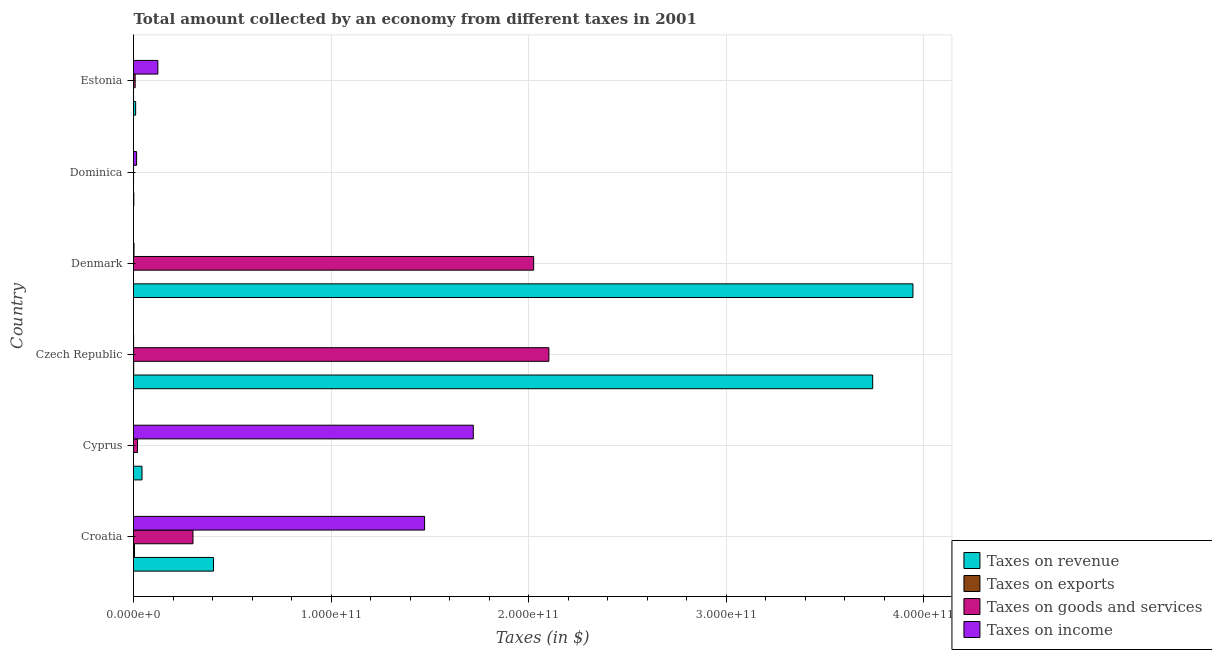How many different coloured bars are there?
Provide a short and direct response. 4. How many groups of bars are there?
Keep it short and to the point. 6. Are the number of bars per tick equal to the number of legend labels?
Your answer should be very brief. Yes. How many bars are there on the 5th tick from the bottom?
Make the answer very short. 4. What is the label of the 6th group of bars from the top?
Provide a short and direct response. Croatia. What is the amount collected as tax on exports in Croatia?
Your response must be concise. 4.93e+08. Across all countries, what is the maximum amount collected as tax on goods?
Your response must be concise. 2.10e+11. Across all countries, what is the minimum amount collected as tax on revenue?
Your response must be concise. 1.63e+08. In which country was the amount collected as tax on income maximum?
Offer a terse response. Cyprus. In which country was the amount collected as tax on goods minimum?
Provide a succinct answer. Dominica. What is the total amount collected as tax on exports in the graph?
Your answer should be very brief. 6.10e+08. What is the difference between the amount collected as tax on goods in Croatia and that in Cyprus?
Ensure brevity in your answer.  2.81e+1. What is the difference between the amount collected as tax on revenue in Croatia and the amount collected as tax on goods in Cyprus?
Offer a terse response. 3.85e+1. What is the average amount collected as tax on revenue per country?
Keep it short and to the point. 1.36e+11. What is the difference between the amount collected as tax on income and amount collected as tax on exports in Denmark?
Your response must be concise. 2.48e+08. What is the ratio of the amount collected as tax on income in Croatia to that in Dominica?
Provide a short and direct response. 93.61. Is the amount collected as tax on exports in Croatia less than that in Denmark?
Ensure brevity in your answer.  No. Is the difference between the amount collected as tax on goods in Cyprus and Estonia greater than the difference between the amount collected as tax on revenue in Cyprus and Estonia?
Provide a succinct answer. No. What is the difference between the highest and the second highest amount collected as tax on goods?
Make the answer very short. 7.71e+09. What is the difference between the highest and the lowest amount collected as tax on income?
Ensure brevity in your answer.  1.72e+11. What does the 1st bar from the top in Cyprus represents?
Make the answer very short. Taxes on income. What does the 1st bar from the bottom in Denmark represents?
Offer a terse response. Taxes on revenue. How many bars are there?
Make the answer very short. 24. What is the difference between two consecutive major ticks on the X-axis?
Offer a very short reply. 1.00e+11. Are the values on the major ticks of X-axis written in scientific E-notation?
Your answer should be compact. Yes. Does the graph contain grids?
Make the answer very short. Yes. What is the title of the graph?
Your response must be concise. Total amount collected by an economy from different taxes in 2001. Does "Quality of logistic services" appear as one of the legend labels in the graph?
Give a very brief answer. No. What is the label or title of the X-axis?
Offer a terse response. Taxes (in $). What is the Taxes (in $) in Taxes on revenue in Croatia?
Give a very brief answer. 4.05e+1. What is the Taxes (in $) in Taxes on exports in Croatia?
Make the answer very short. 4.93e+08. What is the Taxes (in $) of Taxes on goods and services in Croatia?
Keep it short and to the point. 3.01e+1. What is the Taxes (in $) of Taxes on income in Croatia?
Provide a short and direct response. 1.47e+11. What is the Taxes (in $) of Taxes on revenue in Cyprus?
Give a very brief answer. 4.30e+09. What is the Taxes (in $) of Taxes on goods and services in Cyprus?
Make the answer very short. 2.02e+09. What is the Taxes (in $) in Taxes on income in Cyprus?
Make the answer very short. 1.72e+11. What is the Taxes (in $) of Taxes on revenue in Czech Republic?
Offer a terse response. 3.74e+11. What is the Taxes (in $) of Taxes on exports in Czech Republic?
Provide a succinct answer. 9.83e+07. What is the Taxes (in $) in Taxes on goods and services in Czech Republic?
Make the answer very short. 2.10e+11. What is the Taxes (in $) of Taxes on income in Czech Republic?
Ensure brevity in your answer.  4.45e+07. What is the Taxes (in $) in Taxes on revenue in Denmark?
Give a very brief answer. 3.95e+11. What is the Taxes (in $) of Taxes on exports in Denmark?
Provide a succinct answer. 1.96e+06. What is the Taxes (in $) in Taxes on goods and services in Denmark?
Offer a very short reply. 2.03e+11. What is the Taxes (in $) of Taxes on income in Denmark?
Keep it short and to the point. 2.50e+08. What is the Taxes (in $) of Taxes on revenue in Dominica?
Ensure brevity in your answer.  1.63e+08. What is the Taxes (in $) of Taxes on exports in Dominica?
Give a very brief answer. 9.30e+06. What is the Taxes (in $) in Taxes on goods and services in Dominica?
Keep it short and to the point. 3.03e+07. What is the Taxes (in $) in Taxes on income in Dominica?
Your answer should be very brief. 1.57e+09. What is the Taxes (in $) of Taxes on revenue in Estonia?
Your answer should be very brief. 1.08e+09. What is the Taxes (in $) of Taxes on exports in Estonia?
Ensure brevity in your answer.  7.40e+06. What is the Taxes (in $) of Taxes on goods and services in Estonia?
Offer a very short reply. 8.27e+08. What is the Taxes (in $) in Taxes on income in Estonia?
Offer a terse response. 1.23e+1. Across all countries, what is the maximum Taxes (in $) of Taxes on revenue?
Make the answer very short. 3.95e+11. Across all countries, what is the maximum Taxes (in $) in Taxes on exports?
Give a very brief answer. 4.93e+08. Across all countries, what is the maximum Taxes (in $) of Taxes on goods and services?
Make the answer very short. 2.10e+11. Across all countries, what is the maximum Taxes (in $) of Taxes on income?
Your answer should be very brief. 1.72e+11. Across all countries, what is the minimum Taxes (in $) in Taxes on revenue?
Your answer should be compact. 1.63e+08. Across all countries, what is the minimum Taxes (in $) of Taxes on goods and services?
Provide a succinct answer. 3.03e+07. Across all countries, what is the minimum Taxes (in $) of Taxes on income?
Keep it short and to the point. 4.45e+07. What is the total Taxes (in $) in Taxes on revenue in the graph?
Offer a terse response. 8.15e+11. What is the total Taxes (in $) of Taxes on exports in the graph?
Ensure brevity in your answer.  6.10e+08. What is the total Taxes (in $) in Taxes on goods and services in the graph?
Make the answer very short. 4.46e+11. What is the total Taxes (in $) of Taxes on income in the graph?
Make the answer very short. 3.34e+11. What is the difference between the Taxes (in $) in Taxes on revenue in Croatia and that in Cyprus?
Keep it short and to the point. 3.62e+1. What is the difference between the Taxes (in $) in Taxes on exports in Croatia and that in Cyprus?
Make the answer very short. 4.93e+08. What is the difference between the Taxes (in $) of Taxes on goods and services in Croatia and that in Cyprus?
Provide a short and direct response. 2.81e+1. What is the difference between the Taxes (in $) in Taxes on income in Croatia and that in Cyprus?
Your response must be concise. -2.47e+1. What is the difference between the Taxes (in $) in Taxes on revenue in Croatia and that in Czech Republic?
Provide a succinct answer. -3.34e+11. What is the difference between the Taxes (in $) of Taxes on exports in Croatia and that in Czech Republic?
Ensure brevity in your answer.  3.95e+08. What is the difference between the Taxes (in $) of Taxes on goods and services in Croatia and that in Czech Republic?
Keep it short and to the point. -1.80e+11. What is the difference between the Taxes (in $) of Taxes on income in Croatia and that in Czech Republic?
Offer a very short reply. 1.47e+11. What is the difference between the Taxes (in $) in Taxes on revenue in Croatia and that in Denmark?
Your answer should be very brief. -3.54e+11. What is the difference between the Taxes (in $) of Taxes on exports in Croatia and that in Denmark?
Your answer should be very brief. 4.91e+08. What is the difference between the Taxes (in $) in Taxes on goods and services in Croatia and that in Denmark?
Your answer should be compact. -1.73e+11. What is the difference between the Taxes (in $) of Taxes on income in Croatia and that in Denmark?
Ensure brevity in your answer.  1.47e+11. What is the difference between the Taxes (in $) of Taxes on revenue in Croatia and that in Dominica?
Keep it short and to the point. 4.03e+1. What is the difference between the Taxes (in $) in Taxes on exports in Croatia and that in Dominica?
Ensure brevity in your answer.  4.84e+08. What is the difference between the Taxes (in $) of Taxes on goods and services in Croatia and that in Dominica?
Your response must be concise. 3.01e+1. What is the difference between the Taxes (in $) of Taxes on income in Croatia and that in Dominica?
Make the answer very short. 1.46e+11. What is the difference between the Taxes (in $) in Taxes on revenue in Croatia and that in Estonia?
Provide a short and direct response. 3.94e+1. What is the difference between the Taxes (in $) in Taxes on exports in Croatia and that in Estonia?
Your response must be concise. 4.86e+08. What is the difference between the Taxes (in $) of Taxes on goods and services in Croatia and that in Estonia?
Your answer should be compact. 2.93e+1. What is the difference between the Taxes (in $) in Taxes on income in Croatia and that in Estonia?
Make the answer very short. 1.35e+11. What is the difference between the Taxes (in $) in Taxes on revenue in Cyprus and that in Czech Republic?
Provide a short and direct response. -3.70e+11. What is the difference between the Taxes (in $) of Taxes on exports in Cyprus and that in Czech Republic?
Provide a succinct answer. -9.83e+07. What is the difference between the Taxes (in $) in Taxes on goods and services in Cyprus and that in Czech Republic?
Ensure brevity in your answer.  -2.08e+11. What is the difference between the Taxes (in $) in Taxes on income in Cyprus and that in Czech Republic?
Offer a very short reply. 1.72e+11. What is the difference between the Taxes (in $) in Taxes on revenue in Cyprus and that in Denmark?
Make the answer very short. -3.90e+11. What is the difference between the Taxes (in $) of Taxes on exports in Cyprus and that in Denmark?
Make the answer very short. -1.92e+06. What is the difference between the Taxes (in $) of Taxes on goods and services in Cyprus and that in Denmark?
Your answer should be very brief. -2.01e+11. What is the difference between the Taxes (in $) of Taxes on income in Cyprus and that in Denmark?
Provide a succinct answer. 1.72e+11. What is the difference between the Taxes (in $) of Taxes on revenue in Cyprus and that in Dominica?
Your answer should be very brief. 4.14e+09. What is the difference between the Taxes (in $) in Taxes on exports in Cyprus and that in Dominica?
Keep it short and to the point. -9.26e+06. What is the difference between the Taxes (in $) in Taxes on goods and services in Cyprus and that in Dominica?
Provide a short and direct response. 1.99e+09. What is the difference between the Taxes (in $) of Taxes on income in Cyprus and that in Dominica?
Provide a short and direct response. 1.70e+11. What is the difference between the Taxes (in $) of Taxes on revenue in Cyprus and that in Estonia?
Provide a succinct answer. 3.22e+09. What is the difference between the Taxes (in $) of Taxes on exports in Cyprus and that in Estonia?
Your answer should be compact. -7.36e+06. What is the difference between the Taxes (in $) of Taxes on goods and services in Cyprus and that in Estonia?
Your response must be concise. 1.20e+09. What is the difference between the Taxes (in $) of Taxes on income in Cyprus and that in Estonia?
Offer a very short reply. 1.60e+11. What is the difference between the Taxes (in $) of Taxes on revenue in Czech Republic and that in Denmark?
Offer a terse response. -2.04e+1. What is the difference between the Taxes (in $) of Taxes on exports in Czech Republic and that in Denmark?
Give a very brief answer. 9.64e+07. What is the difference between the Taxes (in $) in Taxes on goods and services in Czech Republic and that in Denmark?
Your answer should be very brief. 7.71e+09. What is the difference between the Taxes (in $) of Taxes on income in Czech Republic and that in Denmark?
Provide a short and direct response. -2.05e+08. What is the difference between the Taxes (in $) of Taxes on revenue in Czech Republic and that in Dominica?
Your response must be concise. 3.74e+11. What is the difference between the Taxes (in $) in Taxes on exports in Czech Republic and that in Dominica?
Your answer should be compact. 8.90e+07. What is the difference between the Taxes (in $) of Taxes on goods and services in Czech Republic and that in Dominica?
Keep it short and to the point. 2.10e+11. What is the difference between the Taxes (in $) of Taxes on income in Czech Republic and that in Dominica?
Provide a short and direct response. -1.53e+09. What is the difference between the Taxes (in $) of Taxes on revenue in Czech Republic and that in Estonia?
Your response must be concise. 3.73e+11. What is the difference between the Taxes (in $) in Taxes on exports in Czech Republic and that in Estonia?
Offer a terse response. 9.09e+07. What is the difference between the Taxes (in $) in Taxes on goods and services in Czech Republic and that in Estonia?
Provide a short and direct response. 2.09e+11. What is the difference between the Taxes (in $) of Taxes on income in Czech Republic and that in Estonia?
Give a very brief answer. -1.23e+1. What is the difference between the Taxes (in $) of Taxes on revenue in Denmark and that in Dominica?
Make the answer very short. 3.95e+11. What is the difference between the Taxes (in $) in Taxes on exports in Denmark and that in Dominica?
Your answer should be compact. -7.34e+06. What is the difference between the Taxes (in $) of Taxes on goods and services in Denmark and that in Dominica?
Offer a very short reply. 2.03e+11. What is the difference between the Taxes (in $) of Taxes on income in Denmark and that in Dominica?
Offer a terse response. -1.32e+09. What is the difference between the Taxes (in $) of Taxes on revenue in Denmark and that in Estonia?
Offer a terse response. 3.94e+11. What is the difference between the Taxes (in $) in Taxes on exports in Denmark and that in Estonia?
Give a very brief answer. -5.44e+06. What is the difference between the Taxes (in $) of Taxes on goods and services in Denmark and that in Estonia?
Offer a terse response. 2.02e+11. What is the difference between the Taxes (in $) of Taxes on income in Denmark and that in Estonia?
Provide a short and direct response. -1.21e+1. What is the difference between the Taxes (in $) in Taxes on revenue in Dominica and that in Estonia?
Make the answer very short. -9.16e+08. What is the difference between the Taxes (in $) of Taxes on exports in Dominica and that in Estonia?
Keep it short and to the point. 1.90e+06. What is the difference between the Taxes (in $) in Taxes on goods and services in Dominica and that in Estonia?
Ensure brevity in your answer.  -7.97e+08. What is the difference between the Taxes (in $) of Taxes on income in Dominica and that in Estonia?
Ensure brevity in your answer.  -1.08e+1. What is the difference between the Taxes (in $) of Taxes on revenue in Croatia and the Taxes (in $) of Taxes on exports in Cyprus?
Offer a terse response. 4.05e+1. What is the difference between the Taxes (in $) in Taxes on revenue in Croatia and the Taxes (in $) in Taxes on goods and services in Cyprus?
Your response must be concise. 3.85e+1. What is the difference between the Taxes (in $) in Taxes on revenue in Croatia and the Taxes (in $) in Taxes on income in Cyprus?
Your answer should be very brief. -1.32e+11. What is the difference between the Taxes (in $) of Taxes on exports in Croatia and the Taxes (in $) of Taxes on goods and services in Cyprus?
Your answer should be compact. -1.53e+09. What is the difference between the Taxes (in $) of Taxes on exports in Croatia and the Taxes (in $) of Taxes on income in Cyprus?
Give a very brief answer. -1.72e+11. What is the difference between the Taxes (in $) in Taxes on goods and services in Croatia and the Taxes (in $) in Taxes on income in Cyprus?
Your response must be concise. -1.42e+11. What is the difference between the Taxes (in $) in Taxes on revenue in Croatia and the Taxes (in $) in Taxes on exports in Czech Republic?
Your answer should be very brief. 4.04e+1. What is the difference between the Taxes (in $) of Taxes on revenue in Croatia and the Taxes (in $) of Taxes on goods and services in Czech Republic?
Make the answer very short. -1.70e+11. What is the difference between the Taxes (in $) in Taxes on revenue in Croatia and the Taxes (in $) in Taxes on income in Czech Republic?
Your response must be concise. 4.04e+1. What is the difference between the Taxes (in $) of Taxes on exports in Croatia and the Taxes (in $) of Taxes on goods and services in Czech Republic?
Make the answer very short. -2.10e+11. What is the difference between the Taxes (in $) in Taxes on exports in Croatia and the Taxes (in $) in Taxes on income in Czech Republic?
Your answer should be compact. 4.48e+08. What is the difference between the Taxes (in $) of Taxes on goods and services in Croatia and the Taxes (in $) of Taxes on income in Czech Republic?
Your answer should be compact. 3.01e+1. What is the difference between the Taxes (in $) of Taxes on revenue in Croatia and the Taxes (in $) of Taxes on exports in Denmark?
Provide a short and direct response. 4.05e+1. What is the difference between the Taxes (in $) of Taxes on revenue in Croatia and the Taxes (in $) of Taxes on goods and services in Denmark?
Provide a short and direct response. -1.62e+11. What is the difference between the Taxes (in $) of Taxes on revenue in Croatia and the Taxes (in $) of Taxes on income in Denmark?
Offer a very short reply. 4.02e+1. What is the difference between the Taxes (in $) in Taxes on exports in Croatia and the Taxes (in $) in Taxes on goods and services in Denmark?
Ensure brevity in your answer.  -2.02e+11. What is the difference between the Taxes (in $) of Taxes on exports in Croatia and the Taxes (in $) of Taxes on income in Denmark?
Ensure brevity in your answer.  2.43e+08. What is the difference between the Taxes (in $) in Taxes on goods and services in Croatia and the Taxes (in $) in Taxes on income in Denmark?
Offer a terse response. 2.99e+1. What is the difference between the Taxes (in $) in Taxes on revenue in Croatia and the Taxes (in $) in Taxes on exports in Dominica?
Provide a short and direct response. 4.05e+1. What is the difference between the Taxes (in $) in Taxes on revenue in Croatia and the Taxes (in $) in Taxes on goods and services in Dominica?
Keep it short and to the point. 4.05e+1. What is the difference between the Taxes (in $) of Taxes on revenue in Croatia and the Taxes (in $) of Taxes on income in Dominica?
Provide a succinct answer. 3.89e+1. What is the difference between the Taxes (in $) of Taxes on exports in Croatia and the Taxes (in $) of Taxes on goods and services in Dominica?
Ensure brevity in your answer.  4.63e+08. What is the difference between the Taxes (in $) of Taxes on exports in Croatia and the Taxes (in $) of Taxes on income in Dominica?
Ensure brevity in your answer.  -1.08e+09. What is the difference between the Taxes (in $) in Taxes on goods and services in Croatia and the Taxes (in $) in Taxes on income in Dominica?
Offer a terse response. 2.85e+1. What is the difference between the Taxes (in $) in Taxes on revenue in Croatia and the Taxes (in $) in Taxes on exports in Estonia?
Offer a terse response. 4.05e+1. What is the difference between the Taxes (in $) in Taxes on revenue in Croatia and the Taxes (in $) in Taxes on goods and services in Estonia?
Provide a short and direct response. 3.97e+1. What is the difference between the Taxes (in $) in Taxes on revenue in Croatia and the Taxes (in $) in Taxes on income in Estonia?
Make the answer very short. 2.81e+1. What is the difference between the Taxes (in $) in Taxes on exports in Croatia and the Taxes (in $) in Taxes on goods and services in Estonia?
Provide a short and direct response. -3.34e+08. What is the difference between the Taxes (in $) in Taxes on exports in Croatia and the Taxes (in $) in Taxes on income in Estonia?
Offer a very short reply. -1.18e+1. What is the difference between the Taxes (in $) of Taxes on goods and services in Croatia and the Taxes (in $) of Taxes on income in Estonia?
Make the answer very short. 1.78e+1. What is the difference between the Taxes (in $) of Taxes on revenue in Cyprus and the Taxes (in $) of Taxes on exports in Czech Republic?
Offer a very short reply. 4.20e+09. What is the difference between the Taxes (in $) in Taxes on revenue in Cyprus and the Taxes (in $) in Taxes on goods and services in Czech Republic?
Ensure brevity in your answer.  -2.06e+11. What is the difference between the Taxes (in $) in Taxes on revenue in Cyprus and the Taxes (in $) in Taxes on income in Czech Republic?
Offer a terse response. 4.26e+09. What is the difference between the Taxes (in $) of Taxes on exports in Cyprus and the Taxes (in $) of Taxes on goods and services in Czech Republic?
Provide a short and direct response. -2.10e+11. What is the difference between the Taxes (in $) of Taxes on exports in Cyprus and the Taxes (in $) of Taxes on income in Czech Republic?
Ensure brevity in your answer.  -4.45e+07. What is the difference between the Taxes (in $) in Taxes on goods and services in Cyprus and the Taxes (in $) in Taxes on income in Czech Republic?
Provide a succinct answer. 1.98e+09. What is the difference between the Taxes (in $) in Taxes on revenue in Cyprus and the Taxes (in $) in Taxes on exports in Denmark?
Give a very brief answer. 4.30e+09. What is the difference between the Taxes (in $) of Taxes on revenue in Cyprus and the Taxes (in $) of Taxes on goods and services in Denmark?
Your answer should be compact. -1.98e+11. What is the difference between the Taxes (in $) of Taxes on revenue in Cyprus and the Taxes (in $) of Taxes on income in Denmark?
Give a very brief answer. 4.05e+09. What is the difference between the Taxes (in $) of Taxes on exports in Cyprus and the Taxes (in $) of Taxes on goods and services in Denmark?
Offer a terse response. -2.03e+11. What is the difference between the Taxes (in $) of Taxes on exports in Cyprus and the Taxes (in $) of Taxes on income in Denmark?
Offer a terse response. -2.50e+08. What is the difference between the Taxes (in $) of Taxes on goods and services in Cyprus and the Taxes (in $) of Taxes on income in Denmark?
Keep it short and to the point. 1.77e+09. What is the difference between the Taxes (in $) in Taxes on revenue in Cyprus and the Taxes (in $) in Taxes on exports in Dominica?
Your answer should be compact. 4.29e+09. What is the difference between the Taxes (in $) of Taxes on revenue in Cyprus and the Taxes (in $) of Taxes on goods and services in Dominica?
Your answer should be very brief. 4.27e+09. What is the difference between the Taxes (in $) in Taxes on revenue in Cyprus and the Taxes (in $) in Taxes on income in Dominica?
Make the answer very short. 2.73e+09. What is the difference between the Taxes (in $) in Taxes on exports in Cyprus and the Taxes (in $) in Taxes on goods and services in Dominica?
Your response must be concise. -3.03e+07. What is the difference between the Taxes (in $) in Taxes on exports in Cyprus and the Taxes (in $) in Taxes on income in Dominica?
Provide a succinct answer. -1.57e+09. What is the difference between the Taxes (in $) of Taxes on goods and services in Cyprus and the Taxes (in $) of Taxes on income in Dominica?
Your answer should be compact. 4.49e+08. What is the difference between the Taxes (in $) in Taxes on revenue in Cyprus and the Taxes (in $) in Taxes on exports in Estonia?
Your response must be concise. 4.29e+09. What is the difference between the Taxes (in $) in Taxes on revenue in Cyprus and the Taxes (in $) in Taxes on goods and services in Estonia?
Your answer should be very brief. 3.47e+09. What is the difference between the Taxes (in $) in Taxes on revenue in Cyprus and the Taxes (in $) in Taxes on income in Estonia?
Provide a short and direct response. -8.04e+09. What is the difference between the Taxes (in $) of Taxes on exports in Cyprus and the Taxes (in $) of Taxes on goods and services in Estonia?
Offer a very short reply. -8.27e+08. What is the difference between the Taxes (in $) in Taxes on exports in Cyprus and the Taxes (in $) in Taxes on income in Estonia?
Give a very brief answer. -1.23e+1. What is the difference between the Taxes (in $) in Taxes on goods and services in Cyprus and the Taxes (in $) in Taxes on income in Estonia?
Your answer should be compact. -1.03e+1. What is the difference between the Taxes (in $) in Taxes on revenue in Czech Republic and the Taxes (in $) in Taxes on exports in Denmark?
Give a very brief answer. 3.74e+11. What is the difference between the Taxes (in $) in Taxes on revenue in Czech Republic and the Taxes (in $) in Taxes on goods and services in Denmark?
Provide a short and direct response. 1.72e+11. What is the difference between the Taxes (in $) of Taxes on revenue in Czech Republic and the Taxes (in $) of Taxes on income in Denmark?
Your answer should be compact. 3.74e+11. What is the difference between the Taxes (in $) in Taxes on exports in Czech Republic and the Taxes (in $) in Taxes on goods and services in Denmark?
Offer a very short reply. -2.03e+11. What is the difference between the Taxes (in $) in Taxes on exports in Czech Republic and the Taxes (in $) in Taxes on income in Denmark?
Give a very brief answer. -1.51e+08. What is the difference between the Taxes (in $) of Taxes on goods and services in Czech Republic and the Taxes (in $) of Taxes on income in Denmark?
Provide a succinct answer. 2.10e+11. What is the difference between the Taxes (in $) of Taxes on revenue in Czech Republic and the Taxes (in $) of Taxes on exports in Dominica?
Ensure brevity in your answer.  3.74e+11. What is the difference between the Taxes (in $) of Taxes on revenue in Czech Republic and the Taxes (in $) of Taxes on goods and services in Dominica?
Provide a short and direct response. 3.74e+11. What is the difference between the Taxes (in $) of Taxes on revenue in Czech Republic and the Taxes (in $) of Taxes on income in Dominica?
Your response must be concise. 3.73e+11. What is the difference between the Taxes (in $) of Taxes on exports in Czech Republic and the Taxes (in $) of Taxes on goods and services in Dominica?
Keep it short and to the point. 6.80e+07. What is the difference between the Taxes (in $) in Taxes on exports in Czech Republic and the Taxes (in $) in Taxes on income in Dominica?
Your response must be concise. -1.48e+09. What is the difference between the Taxes (in $) of Taxes on goods and services in Czech Republic and the Taxes (in $) of Taxes on income in Dominica?
Provide a succinct answer. 2.09e+11. What is the difference between the Taxes (in $) of Taxes on revenue in Czech Republic and the Taxes (in $) of Taxes on exports in Estonia?
Make the answer very short. 3.74e+11. What is the difference between the Taxes (in $) in Taxes on revenue in Czech Republic and the Taxes (in $) in Taxes on goods and services in Estonia?
Make the answer very short. 3.73e+11. What is the difference between the Taxes (in $) of Taxes on revenue in Czech Republic and the Taxes (in $) of Taxes on income in Estonia?
Ensure brevity in your answer.  3.62e+11. What is the difference between the Taxes (in $) in Taxes on exports in Czech Republic and the Taxes (in $) in Taxes on goods and services in Estonia?
Your answer should be very brief. -7.29e+08. What is the difference between the Taxes (in $) in Taxes on exports in Czech Republic and the Taxes (in $) in Taxes on income in Estonia?
Your answer should be very brief. -1.22e+1. What is the difference between the Taxes (in $) of Taxes on goods and services in Czech Republic and the Taxes (in $) of Taxes on income in Estonia?
Offer a terse response. 1.98e+11. What is the difference between the Taxes (in $) in Taxes on revenue in Denmark and the Taxes (in $) in Taxes on exports in Dominica?
Your answer should be compact. 3.95e+11. What is the difference between the Taxes (in $) in Taxes on revenue in Denmark and the Taxes (in $) in Taxes on goods and services in Dominica?
Give a very brief answer. 3.95e+11. What is the difference between the Taxes (in $) in Taxes on revenue in Denmark and the Taxes (in $) in Taxes on income in Dominica?
Keep it short and to the point. 3.93e+11. What is the difference between the Taxes (in $) of Taxes on exports in Denmark and the Taxes (in $) of Taxes on goods and services in Dominica?
Offer a very short reply. -2.83e+07. What is the difference between the Taxes (in $) in Taxes on exports in Denmark and the Taxes (in $) in Taxes on income in Dominica?
Your response must be concise. -1.57e+09. What is the difference between the Taxes (in $) in Taxes on goods and services in Denmark and the Taxes (in $) in Taxes on income in Dominica?
Your answer should be compact. 2.01e+11. What is the difference between the Taxes (in $) of Taxes on revenue in Denmark and the Taxes (in $) of Taxes on exports in Estonia?
Offer a terse response. 3.95e+11. What is the difference between the Taxes (in $) of Taxes on revenue in Denmark and the Taxes (in $) of Taxes on goods and services in Estonia?
Provide a short and direct response. 3.94e+11. What is the difference between the Taxes (in $) in Taxes on revenue in Denmark and the Taxes (in $) in Taxes on income in Estonia?
Your answer should be compact. 3.82e+11. What is the difference between the Taxes (in $) in Taxes on exports in Denmark and the Taxes (in $) in Taxes on goods and services in Estonia?
Give a very brief answer. -8.25e+08. What is the difference between the Taxes (in $) in Taxes on exports in Denmark and the Taxes (in $) in Taxes on income in Estonia?
Your response must be concise. -1.23e+1. What is the difference between the Taxes (in $) of Taxes on goods and services in Denmark and the Taxes (in $) of Taxes on income in Estonia?
Your answer should be compact. 1.90e+11. What is the difference between the Taxes (in $) of Taxes on revenue in Dominica and the Taxes (in $) of Taxes on exports in Estonia?
Make the answer very short. 1.56e+08. What is the difference between the Taxes (in $) in Taxes on revenue in Dominica and the Taxes (in $) in Taxes on goods and services in Estonia?
Your answer should be very brief. -6.64e+08. What is the difference between the Taxes (in $) of Taxes on revenue in Dominica and the Taxes (in $) of Taxes on income in Estonia?
Give a very brief answer. -1.22e+1. What is the difference between the Taxes (in $) of Taxes on exports in Dominica and the Taxes (in $) of Taxes on goods and services in Estonia?
Ensure brevity in your answer.  -8.18e+08. What is the difference between the Taxes (in $) of Taxes on exports in Dominica and the Taxes (in $) of Taxes on income in Estonia?
Ensure brevity in your answer.  -1.23e+1. What is the difference between the Taxes (in $) in Taxes on goods and services in Dominica and the Taxes (in $) in Taxes on income in Estonia?
Offer a very short reply. -1.23e+1. What is the average Taxes (in $) in Taxes on revenue per country?
Provide a short and direct response. 1.36e+11. What is the average Taxes (in $) in Taxes on exports per country?
Provide a succinct answer. 1.02e+08. What is the average Taxes (in $) of Taxes on goods and services per country?
Offer a terse response. 7.43e+1. What is the average Taxes (in $) of Taxes on income per country?
Keep it short and to the point. 5.56e+1. What is the difference between the Taxes (in $) of Taxes on revenue and Taxes (in $) of Taxes on exports in Croatia?
Ensure brevity in your answer.  4.00e+1. What is the difference between the Taxes (in $) of Taxes on revenue and Taxes (in $) of Taxes on goods and services in Croatia?
Offer a terse response. 1.04e+1. What is the difference between the Taxes (in $) in Taxes on revenue and Taxes (in $) in Taxes on income in Croatia?
Offer a very short reply. -1.07e+11. What is the difference between the Taxes (in $) of Taxes on exports and Taxes (in $) of Taxes on goods and services in Croatia?
Your response must be concise. -2.96e+1. What is the difference between the Taxes (in $) of Taxes on exports and Taxes (in $) of Taxes on income in Croatia?
Ensure brevity in your answer.  -1.47e+11. What is the difference between the Taxes (in $) of Taxes on goods and services and Taxes (in $) of Taxes on income in Croatia?
Offer a terse response. -1.17e+11. What is the difference between the Taxes (in $) of Taxes on revenue and Taxes (in $) of Taxes on exports in Cyprus?
Offer a very short reply. 4.30e+09. What is the difference between the Taxes (in $) in Taxes on revenue and Taxes (in $) in Taxes on goods and services in Cyprus?
Provide a short and direct response. 2.28e+09. What is the difference between the Taxes (in $) in Taxes on revenue and Taxes (in $) in Taxes on income in Cyprus?
Make the answer very short. -1.68e+11. What is the difference between the Taxes (in $) in Taxes on exports and Taxes (in $) in Taxes on goods and services in Cyprus?
Make the answer very short. -2.02e+09. What is the difference between the Taxes (in $) of Taxes on exports and Taxes (in $) of Taxes on income in Cyprus?
Offer a terse response. -1.72e+11. What is the difference between the Taxes (in $) in Taxes on goods and services and Taxes (in $) in Taxes on income in Cyprus?
Offer a very short reply. -1.70e+11. What is the difference between the Taxes (in $) of Taxes on revenue and Taxes (in $) of Taxes on exports in Czech Republic?
Ensure brevity in your answer.  3.74e+11. What is the difference between the Taxes (in $) in Taxes on revenue and Taxes (in $) in Taxes on goods and services in Czech Republic?
Your answer should be compact. 1.64e+11. What is the difference between the Taxes (in $) in Taxes on revenue and Taxes (in $) in Taxes on income in Czech Republic?
Ensure brevity in your answer.  3.74e+11. What is the difference between the Taxes (in $) of Taxes on exports and Taxes (in $) of Taxes on goods and services in Czech Republic?
Keep it short and to the point. -2.10e+11. What is the difference between the Taxes (in $) of Taxes on exports and Taxes (in $) of Taxes on income in Czech Republic?
Offer a very short reply. 5.38e+07. What is the difference between the Taxes (in $) of Taxes on goods and services and Taxes (in $) of Taxes on income in Czech Republic?
Give a very brief answer. 2.10e+11. What is the difference between the Taxes (in $) of Taxes on revenue and Taxes (in $) of Taxes on exports in Denmark?
Provide a short and direct response. 3.95e+11. What is the difference between the Taxes (in $) of Taxes on revenue and Taxes (in $) of Taxes on goods and services in Denmark?
Provide a short and direct response. 1.92e+11. What is the difference between the Taxes (in $) in Taxes on revenue and Taxes (in $) in Taxes on income in Denmark?
Make the answer very short. 3.94e+11. What is the difference between the Taxes (in $) in Taxes on exports and Taxes (in $) in Taxes on goods and services in Denmark?
Offer a very short reply. -2.03e+11. What is the difference between the Taxes (in $) in Taxes on exports and Taxes (in $) in Taxes on income in Denmark?
Your answer should be very brief. -2.48e+08. What is the difference between the Taxes (in $) of Taxes on goods and services and Taxes (in $) of Taxes on income in Denmark?
Offer a very short reply. 2.02e+11. What is the difference between the Taxes (in $) in Taxes on revenue and Taxes (in $) in Taxes on exports in Dominica?
Your answer should be compact. 1.54e+08. What is the difference between the Taxes (in $) in Taxes on revenue and Taxes (in $) in Taxes on goods and services in Dominica?
Offer a terse response. 1.33e+08. What is the difference between the Taxes (in $) in Taxes on revenue and Taxes (in $) in Taxes on income in Dominica?
Your answer should be very brief. -1.41e+09. What is the difference between the Taxes (in $) of Taxes on exports and Taxes (in $) of Taxes on goods and services in Dominica?
Offer a very short reply. -2.10e+07. What is the difference between the Taxes (in $) of Taxes on exports and Taxes (in $) of Taxes on income in Dominica?
Provide a succinct answer. -1.57e+09. What is the difference between the Taxes (in $) of Taxes on goods and services and Taxes (in $) of Taxes on income in Dominica?
Provide a short and direct response. -1.54e+09. What is the difference between the Taxes (in $) of Taxes on revenue and Taxes (in $) of Taxes on exports in Estonia?
Make the answer very short. 1.07e+09. What is the difference between the Taxes (in $) in Taxes on revenue and Taxes (in $) in Taxes on goods and services in Estonia?
Ensure brevity in your answer.  2.52e+08. What is the difference between the Taxes (in $) of Taxes on revenue and Taxes (in $) of Taxes on income in Estonia?
Your answer should be very brief. -1.13e+1. What is the difference between the Taxes (in $) of Taxes on exports and Taxes (in $) of Taxes on goods and services in Estonia?
Your answer should be compact. -8.20e+08. What is the difference between the Taxes (in $) of Taxes on exports and Taxes (in $) of Taxes on income in Estonia?
Ensure brevity in your answer.  -1.23e+1. What is the difference between the Taxes (in $) of Taxes on goods and services and Taxes (in $) of Taxes on income in Estonia?
Offer a very short reply. -1.15e+1. What is the ratio of the Taxes (in $) in Taxes on revenue in Croatia to that in Cyprus?
Your answer should be very brief. 9.42. What is the ratio of the Taxes (in $) of Taxes on exports in Croatia to that in Cyprus?
Make the answer very short. 1.23e+04. What is the ratio of the Taxes (in $) of Taxes on goods and services in Croatia to that in Cyprus?
Make the answer very short. 14.88. What is the ratio of the Taxes (in $) of Taxes on income in Croatia to that in Cyprus?
Provide a succinct answer. 0.86. What is the ratio of the Taxes (in $) in Taxes on revenue in Croatia to that in Czech Republic?
Ensure brevity in your answer.  0.11. What is the ratio of the Taxes (in $) in Taxes on exports in Croatia to that in Czech Republic?
Provide a succinct answer. 5.01. What is the ratio of the Taxes (in $) of Taxes on goods and services in Croatia to that in Czech Republic?
Provide a succinct answer. 0.14. What is the ratio of the Taxes (in $) in Taxes on income in Croatia to that in Czech Republic?
Give a very brief answer. 3312.09. What is the ratio of the Taxes (in $) in Taxes on revenue in Croatia to that in Denmark?
Provide a short and direct response. 0.1. What is the ratio of the Taxes (in $) of Taxes on exports in Croatia to that in Denmark?
Your response must be concise. 251.71. What is the ratio of the Taxes (in $) of Taxes on goods and services in Croatia to that in Denmark?
Provide a succinct answer. 0.15. What is the ratio of the Taxes (in $) in Taxes on income in Croatia to that in Denmark?
Provide a succinct answer. 590.52. What is the ratio of the Taxes (in $) of Taxes on revenue in Croatia to that in Dominica?
Provide a succinct answer. 248.57. What is the ratio of the Taxes (in $) in Taxes on exports in Croatia to that in Dominica?
Give a very brief answer. 53.01. What is the ratio of the Taxes (in $) of Taxes on goods and services in Croatia to that in Dominica?
Offer a very short reply. 993.6. What is the ratio of the Taxes (in $) in Taxes on income in Croatia to that in Dominica?
Provide a short and direct response. 93.62. What is the ratio of the Taxes (in $) of Taxes on revenue in Croatia to that in Estonia?
Offer a very short reply. 37.51. What is the ratio of the Taxes (in $) in Taxes on exports in Croatia to that in Estonia?
Your answer should be very brief. 66.62. What is the ratio of the Taxes (in $) in Taxes on goods and services in Croatia to that in Estonia?
Make the answer very short. 36.39. What is the ratio of the Taxes (in $) of Taxes on income in Croatia to that in Estonia?
Keep it short and to the point. 11.94. What is the ratio of the Taxes (in $) of Taxes on revenue in Cyprus to that in Czech Republic?
Your answer should be very brief. 0.01. What is the ratio of the Taxes (in $) in Taxes on exports in Cyprus to that in Czech Republic?
Offer a terse response. 0. What is the ratio of the Taxes (in $) of Taxes on goods and services in Cyprus to that in Czech Republic?
Your answer should be very brief. 0.01. What is the ratio of the Taxes (in $) in Taxes on income in Cyprus to that in Czech Republic?
Offer a very short reply. 3866.47. What is the ratio of the Taxes (in $) of Taxes on revenue in Cyprus to that in Denmark?
Ensure brevity in your answer.  0.01. What is the ratio of the Taxes (in $) of Taxes on exports in Cyprus to that in Denmark?
Your response must be concise. 0.02. What is the ratio of the Taxes (in $) of Taxes on income in Cyprus to that in Denmark?
Offer a terse response. 689.36. What is the ratio of the Taxes (in $) in Taxes on revenue in Cyprus to that in Dominica?
Give a very brief answer. 26.4. What is the ratio of the Taxes (in $) in Taxes on exports in Cyprus to that in Dominica?
Ensure brevity in your answer.  0. What is the ratio of the Taxes (in $) in Taxes on goods and services in Cyprus to that in Dominica?
Provide a succinct answer. 66.77. What is the ratio of the Taxes (in $) in Taxes on income in Cyprus to that in Dominica?
Offer a very short reply. 109.28. What is the ratio of the Taxes (in $) in Taxes on revenue in Cyprus to that in Estonia?
Give a very brief answer. 3.98. What is the ratio of the Taxes (in $) in Taxes on exports in Cyprus to that in Estonia?
Your answer should be compact. 0.01. What is the ratio of the Taxes (in $) in Taxes on goods and services in Cyprus to that in Estonia?
Provide a short and direct response. 2.45. What is the ratio of the Taxes (in $) of Taxes on income in Cyprus to that in Estonia?
Give a very brief answer. 13.94. What is the ratio of the Taxes (in $) of Taxes on revenue in Czech Republic to that in Denmark?
Make the answer very short. 0.95. What is the ratio of the Taxes (in $) of Taxes on exports in Czech Republic to that in Denmark?
Make the answer very short. 50.21. What is the ratio of the Taxes (in $) in Taxes on goods and services in Czech Republic to that in Denmark?
Provide a succinct answer. 1.04. What is the ratio of the Taxes (in $) of Taxes on income in Czech Republic to that in Denmark?
Keep it short and to the point. 0.18. What is the ratio of the Taxes (in $) of Taxes on revenue in Czech Republic to that in Dominica?
Provide a succinct answer. 2297.59. What is the ratio of the Taxes (in $) of Taxes on exports in Czech Republic to that in Dominica?
Give a very brief answer. 10.57. What is the ratio of the Taxes (in $) in Taxes on goods and services in Czech Republic to that in Dominica?
Keep it short and to the point. 6941.49. What is the ratio of the Taxes (in $) in Taxes on income in Czech Republic to that in Dominica?
Ensure brevity in your answer.  0.03. What is the ratio of the Taxes (in $) of Taxes on revenue in Czech Republic to that in Estonia?
Provide a short and direct response. 346.75. What is the ratio of the Taxes (in $) of Taxes on exports in Czech Republic to that in Estonia?
Provide a succinct answer. 13.29. What is the ratio of the Taxes (in $) in Taxes on goods and services in Czech Republic to that in Estonia?
Ensure brevity in your answer.  254.24. What is the ratio of the Taxes (in $) of Taxes on income in Czech Republic to that in Estonia?
Keep it short and to the point. 0. What is the ratio of the Taxes (in $) of Taxes on revenue in Denmark to that in Dominica?
Provide a short and direct response. 2422.74. What is the ratio of the Taxes (in $) of Taxes on exports in Denmark to that in Dominica?
Keep it short and to the point. 0.21. What is the ratio of the Taxes (in $) of Taxes on goods and services in Denmark to that in Dominica?
Provide a short and direct response. 6687.03. What is the ratio of the Taxes (in $) of Taxes on income in Denmark to that in Dominica?
Offer a terse response. 0.16. What is the ratio of the Taxes (in $) in Taxes on revenue in Denmark to that in Estonia?
Give a very brief answer. 365.63. What is the ratio of the Taxes (in $) in Taxes on exports in Denmark to that in Estonia?
Keep it short and to the point. 0.26. What is the ratio of the Taxes (in $) of Taxes on goods and services in Denmark to that in Estonia?
Your answer should be compact. 244.92. What is the ratio of the Taxes (in $) in Taxes on income in Denmark to that in Estonia?
Provide a short and direct response. 0.02. What is the ratio of the Taxes (in $) of Taxes on revenue in Dominica to that in Estonia?
Offer a terse response. 0.15. What is the ratio of the Taxes (in $) in Taxes on exports in Dominica to that in Estonia?
Give a very brief answer. 1.26. What is the ratio of the Taxes (in $) of Taxes on goods and services in Dominica to that in Estonia?
Ensure brevity in your answer.  0.04. What is the ratio of the Taxes (in $) of Taxes on income in Dominica to that in Estonia?
Give a very brief answer. 0.13. What is the difference between the highest and the second highest Taxes (in $) in Taxes on revenue?
Your answer should be compact. 2.04e+1. What is the difference between the highest and the second highest Taxes (in $) of Taxes on exports?
Ensure brevity in your answer.  3.95e+08. What is the difference between the highest and the second highest Taxes (in $) of Taxes on goods and services?
Provide a short and direct response. 7.71e+09. What is the difference between the highest and the second highest Taxes (in $) in Taxes on income?
Your response must be concise. 2.47e+1. What is the difference between the highest and the lowest Taxes (in $) of Taxes on revenue?
Provide a short and direct response. 3.95e+11. What is the difference between the highest and the lowest Taxes (in $) of Taxes on exports?
Give a very brief answer. 4.93e+08. What is the difference between the highest and the lowest Taxes (in $) in Taxes on goods and services?
Provide a short and direct response. 2.10e+11. What is the difference between the highest and the lowest Taxes (in $) of Taxes on income?
Your answer should be compact. 1.72e+11. 